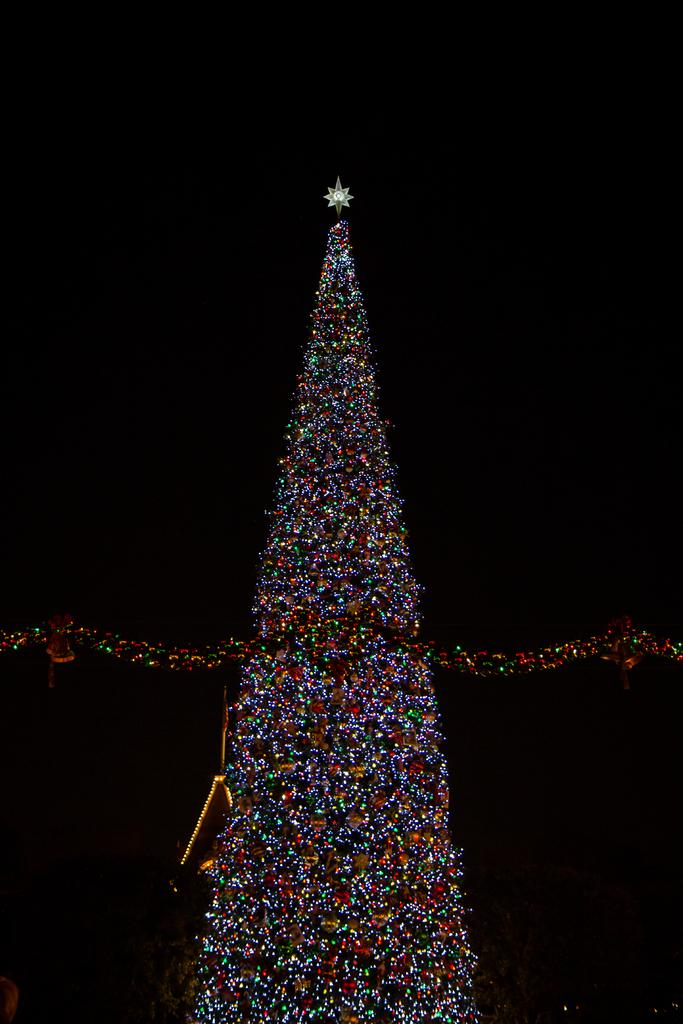What is the main subject of the image? The main subject of the image is lights in the shape of a tower. Can you describe the background of the image? The background of the image is dark. How many teeth can be seen on the scarecrow in the image? There is no scarecrow present in the image, so it is not possible to determine how many teeth it might have. 